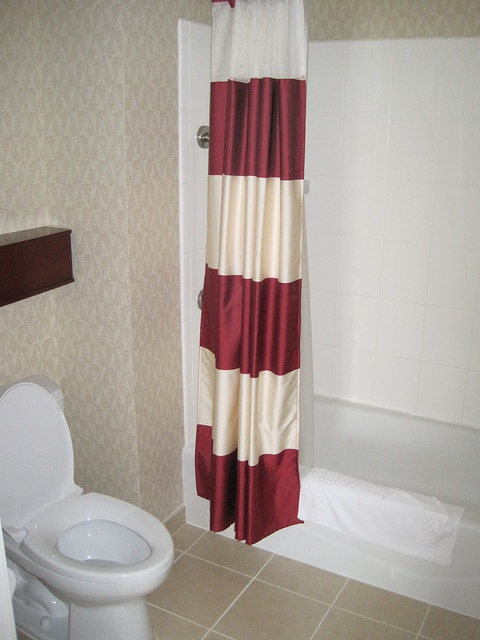Describe the objects in this image and their specific colors. I can see a toilet in gray, darkgray, and lightgray tones in this image. 